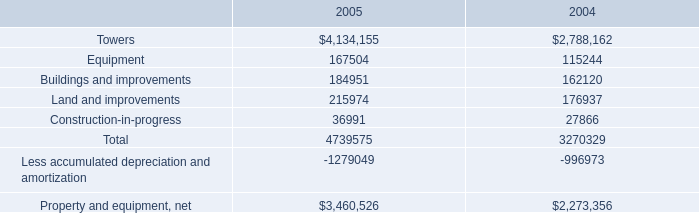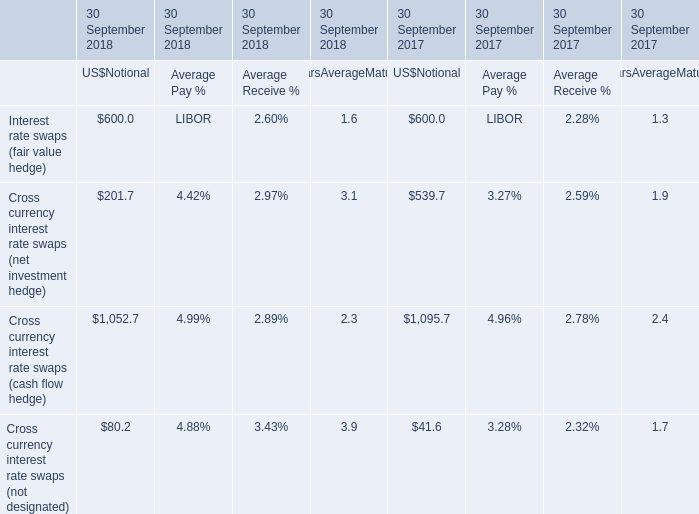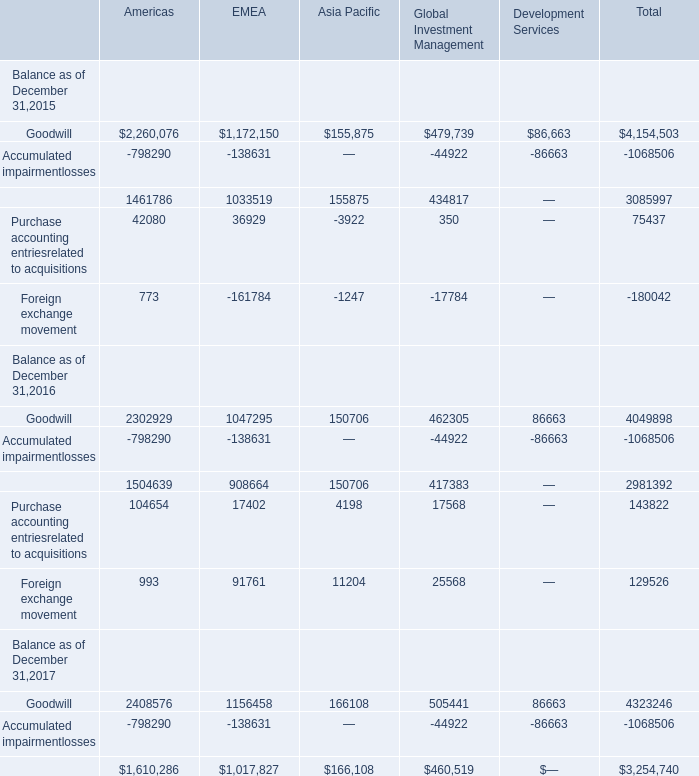What's the growth rate of Goodwill in 2016 for Americas ? (in million) 
Computations: ((2302929 - 2260076) / 2260076)
Answer: 0.01896. 